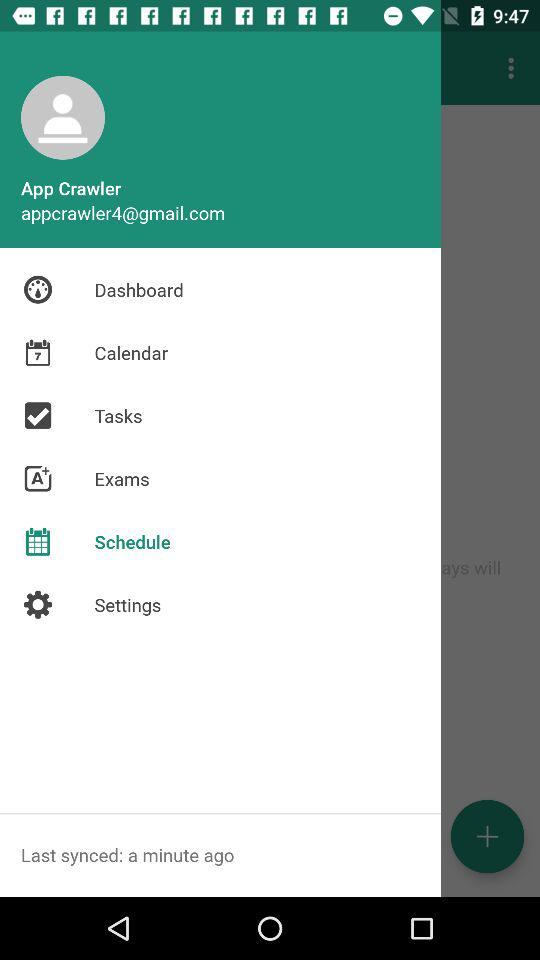What is the email address? The email address is appcrawler4@gmail.com. 